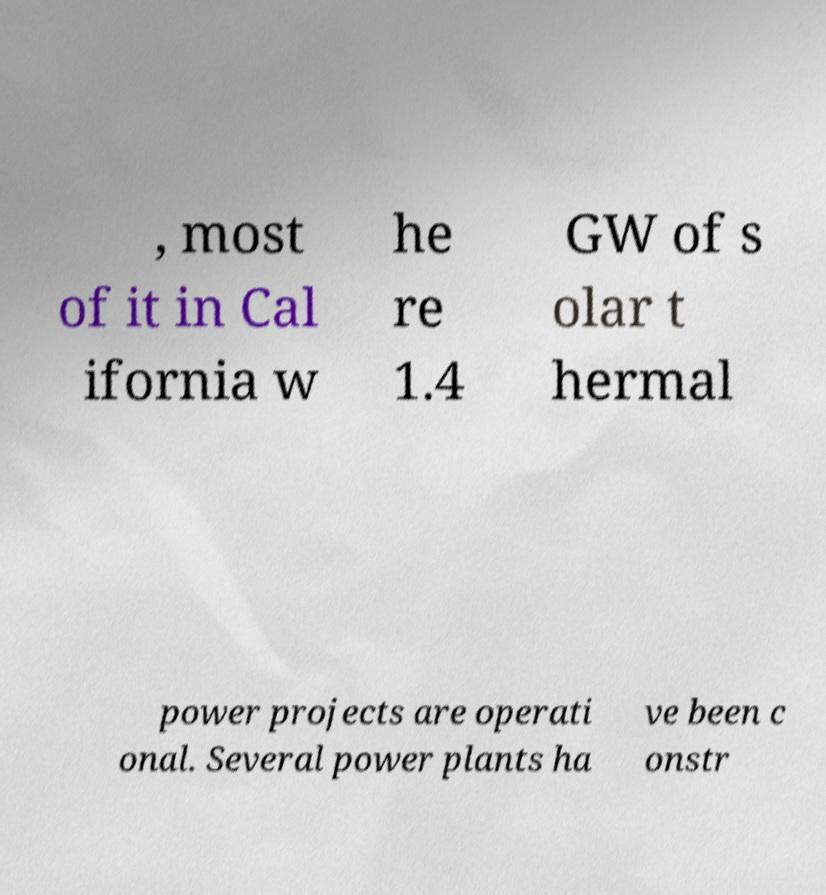Could you extract and type out the text from this image? , most of it in Cal ifornia w he re 1.4 GW of s olar t hermal power projects are operati onal. Several power plants ha ve been c onstr 